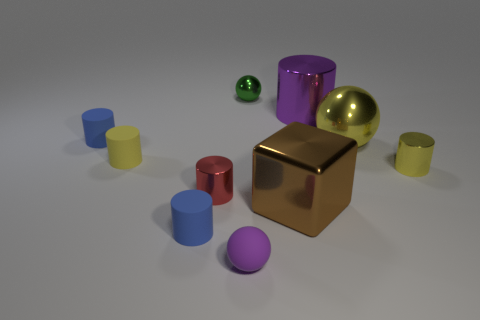Subtract all red shiny cylinders. How many cylinders are left? 5 Subtract all purple cylinders. How many cylinders are left? 5 Subtract all brown cylinders. Subtract all green blocks. How many cylinders are left? 6 Subtract all cylinders. How many objects are left? 4 Subtract 0 gray cylinders. How many objects are left? 10 Subtract all big gray matte things. Subtract all purple metal objects. How many objects are left? 9 Add 9 small purple spheres. How many small purple spheres are left? 10 Add 5 yellow balls. How many yellow balls exist? 6 